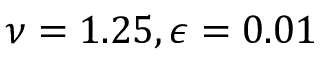Convert formula to latex. <formula><loc_0><loc_0><loc_500><loc_500>\nu = 1 . 2 5 , \epsilon = 0 . 0 1</formula> 